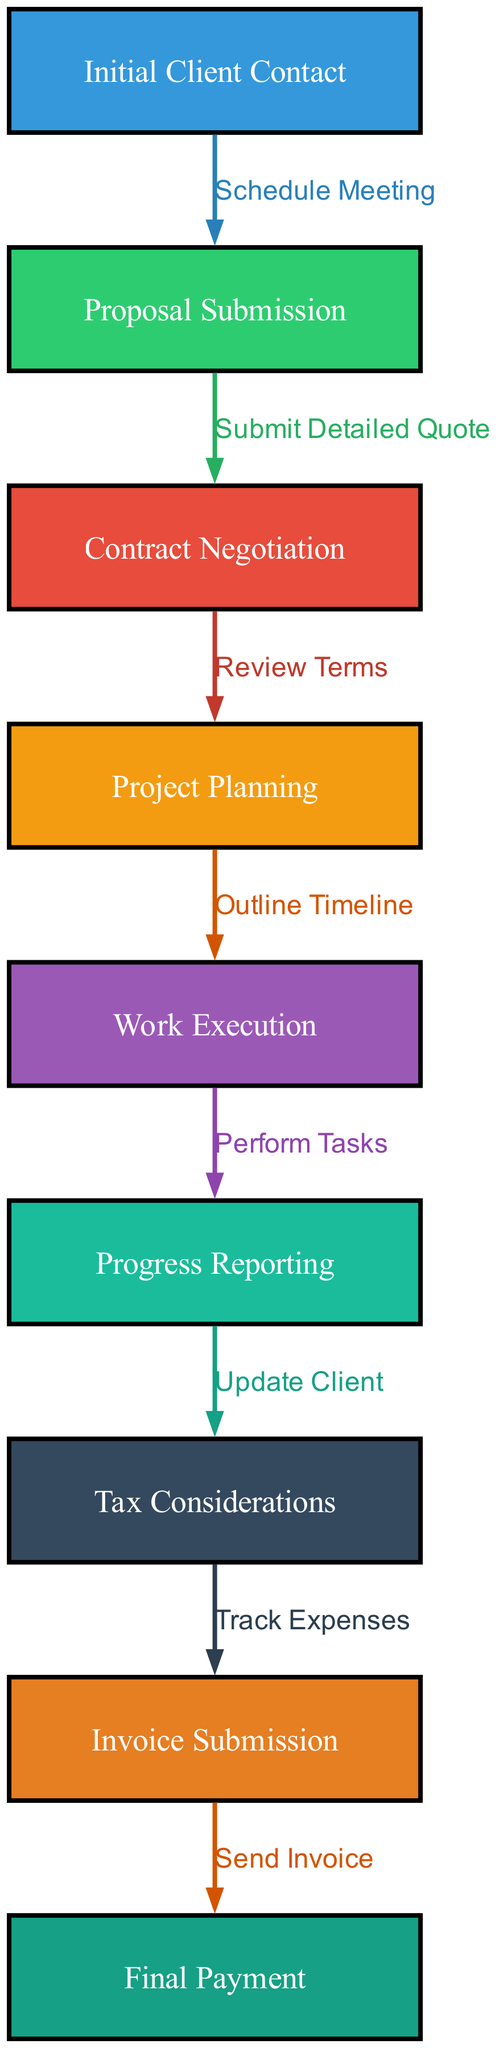What is the first stage in the project workflow? The diagram lists "Initial Client Contact" as the first node, indicating the starting point of the workflow.
Answer: Initial Client Contact How many nodes are in the diagram? By counting the number of distinct stages represented in the nodes, there are a total of 9 nodes in the diagram.
Answer: 9 What color is the node for "Work Execution"? The nodes are colored according to a specific palette, and "Work Execution" corresponds to the color associated with the fifth node, which is a specific shade in the defined palette.
Answer: #f39c12 What is the edge that connects "Proposal Submission" to "Contract Negotiation"? Reviewing the connections (edges) in the diagram, the edge labeled "Review Terms" connects "Proposal Submission" and "Contract Negotiation".
Answer: Review Terms What two nodes are connected by the edge "Send Invoice"? The edge "Send Invoice" connects the node "Invoice Submission" to the next node in the workflow, which is "Final Payment".
Answer: Invoice Submission and Final Payment How many edges are depicted in the diagram? Every transition or connection between two nodes is represented by an edge, and by counting the edges specified in the diagram, we find there are 8 edges.
Answer: 8 What is the last stage before "Final Payment"? By examining the flow of the diagram, the last node immediately preceding "Final Payment" is "Invoice Submission".
Answer: Invoice Submission Which stage involves updating the client? The diagram specifies that "Progress Reporting" is the stage where updates to the client are made.
Answer: Progress Reporting What is one key consideration mentioned in the workflow? The node labeled "Tax Considerations" indicates a specific consideration that must be taken into account during the project workflow.
Answer: Tax Considerations 